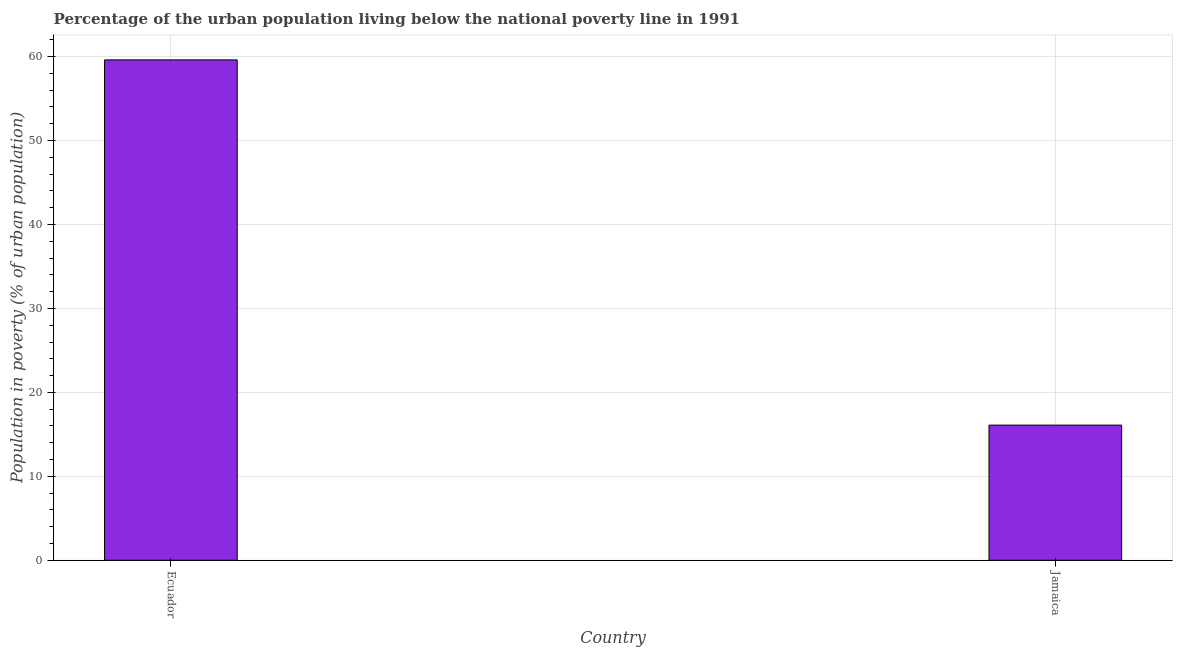What is the title of the graph?
Ensure brevity in your answer.  Percentage of the urban population living below the national poverty line in 1991. What is the label or title of the X-axis?
Your answer should be very brief. Country. What is the label or title of the Y-axis?
Offer a very short reply. Population in poverty (% of urban population). What is the percentage of urban population living below poverty line in Ecuador?
Your answer should be compact. 59.6. Across all countries, what is the maximum percentage of urban population living below poverty line?
Your answer should be very brief. 59.6. In which country was the percentage of urban population living below poverty line maximum?
Your response must be concise. Ecuador. In which country was the percentage of urban population living below poverty line minimum?
Your response must be concise. Jamaica. What is the sum of the percentage of urban population living below poverty line?
Keep it short and to the point. 75.7. What is the difference between the percentage of urban population living below poverty line in Ecuador and Jamaica?
Offer a very short reply. 43.5. What is the average percentage of urban population living below poverty line per country?
Offer a very short reply. 37.85. What is the median percentage of urban population living below poverty line?
Your answer should be compact. 37.85. In how many countries, is the percentage of urban population living below poverty line greater than 28 %?
Make the answer very short. 1. What is the ratio of the percentage of urban population living below poverty line in Ecuador to that in Jamaica?
Provide a short and direct response. 3.7. Is the percentage of urban population living below poverty line in Ecuador less than that in Jamaica?
Your answer should be very brief. No. In how many countries, is the percentage of urban population living below poverty line greater than the average percentage of urban population living below poverty line taken over all countries?
Your answer should be very brief. 1. What is the Population in poverty (% of urban population) of Ecuador?
Your response must be concise. 59.6. What is the Population in poverty (% of urban population) of Jamaica?
Give a very brief answer. 16.1. What is the difference between the Population in poverty (% of urban population) in Ecuador and Jamaica?
Provide a succinct answer. 43.5. What is the ratio of the Population in poverty (% of urban population) in Ecuador to that in Jamaica?
Provide a succinct answer. 3.7. 